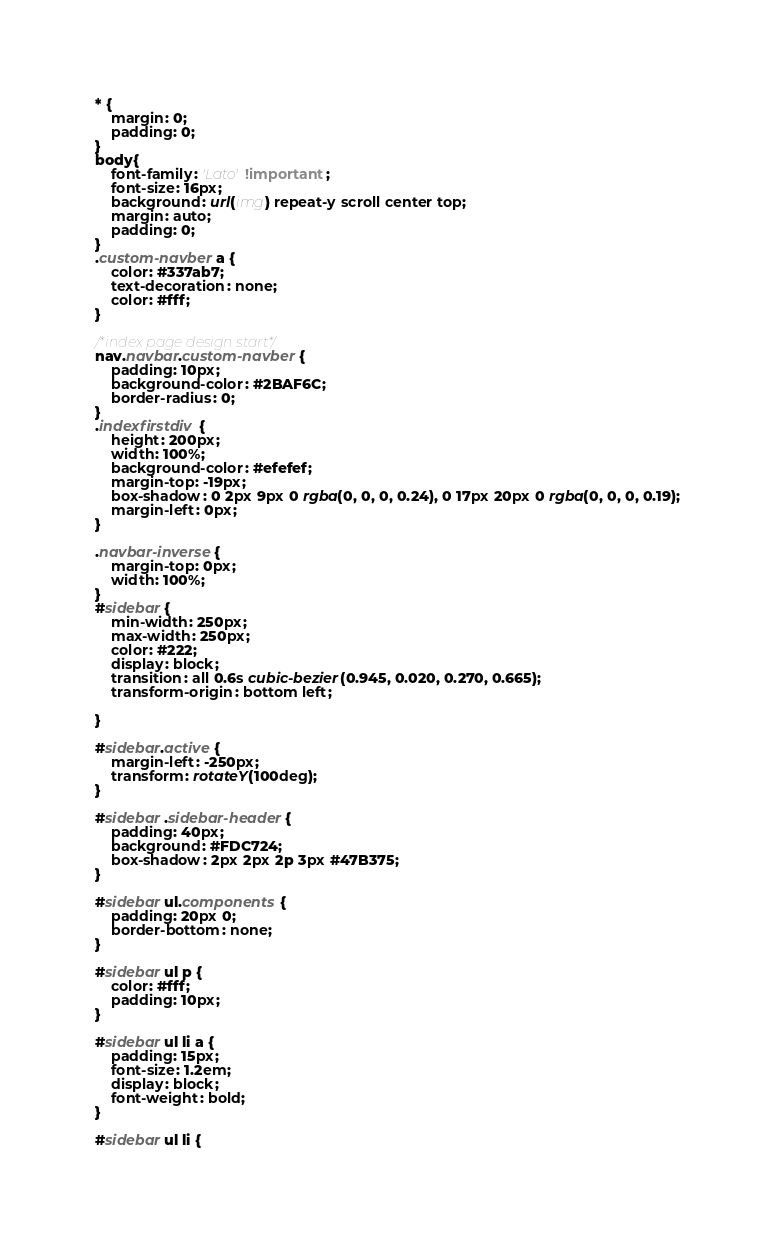Convert code to text. <code><loc_0><loc_0><loc_500><loc_500><_CSS_>* {
    margin: 0;
    padding: 0;
}
body{
    font-family: 'Lato' !important;
    font-size: 16px;
    background: url(img) repeat-y scroll center top;
    margin: auto;
    padding: 0;
}
.custom-navber a {
    color: #337ab7;
    text-decoration: none;
    color: #fff;
}

/*index page design start*/
nav.navbar.custom-navber {
    padding: 10px;
    background-color: #2BAF6C;
    border-radius: 0;
}
.indexfirstdiv {
    height: 200px;
    width: 100%;
    background-color: #efefef;
    margin-top: -19px;
    box-shadow: 0 2px 9px 0 rgba(0, 0, 0, 0.24), 0 17px 20px 0 rgba(0, 0, 0, 0.19);
    margin-left: 0px;
}

.navbar-inverse {
    margin-top: 0px;
    width: 100%;
}
#sidebar {
    min-width: 250px;
    max-width: 250px;
    color: #222;
    display: block;
    transition: all 0.6s cubic-bezier(0.945, 0.020, 0.270, 0.665);
    transform-origin: bottom left;
   
}

#sidebar.active {
    margin-left: -250px;
    transform: rotateY(100deg);
}

#sidebar .sidebar-header {
    padding: 40px;
    background: #FDC724;
    box-shadow: 2px 2px 2p 3px #47B375;
}

#sidebar ul.components {
    padding: 20px 0;
    border-bottom: none;
}

#sidebar ul p {
    color: #fff;
    padding: 10px;
}

#sidebar ul li a {
    padding: 15px;
    font-size: 1.2em;
    display: block;
    font-weight: bold;
}

#sidebar ul li {</code> 